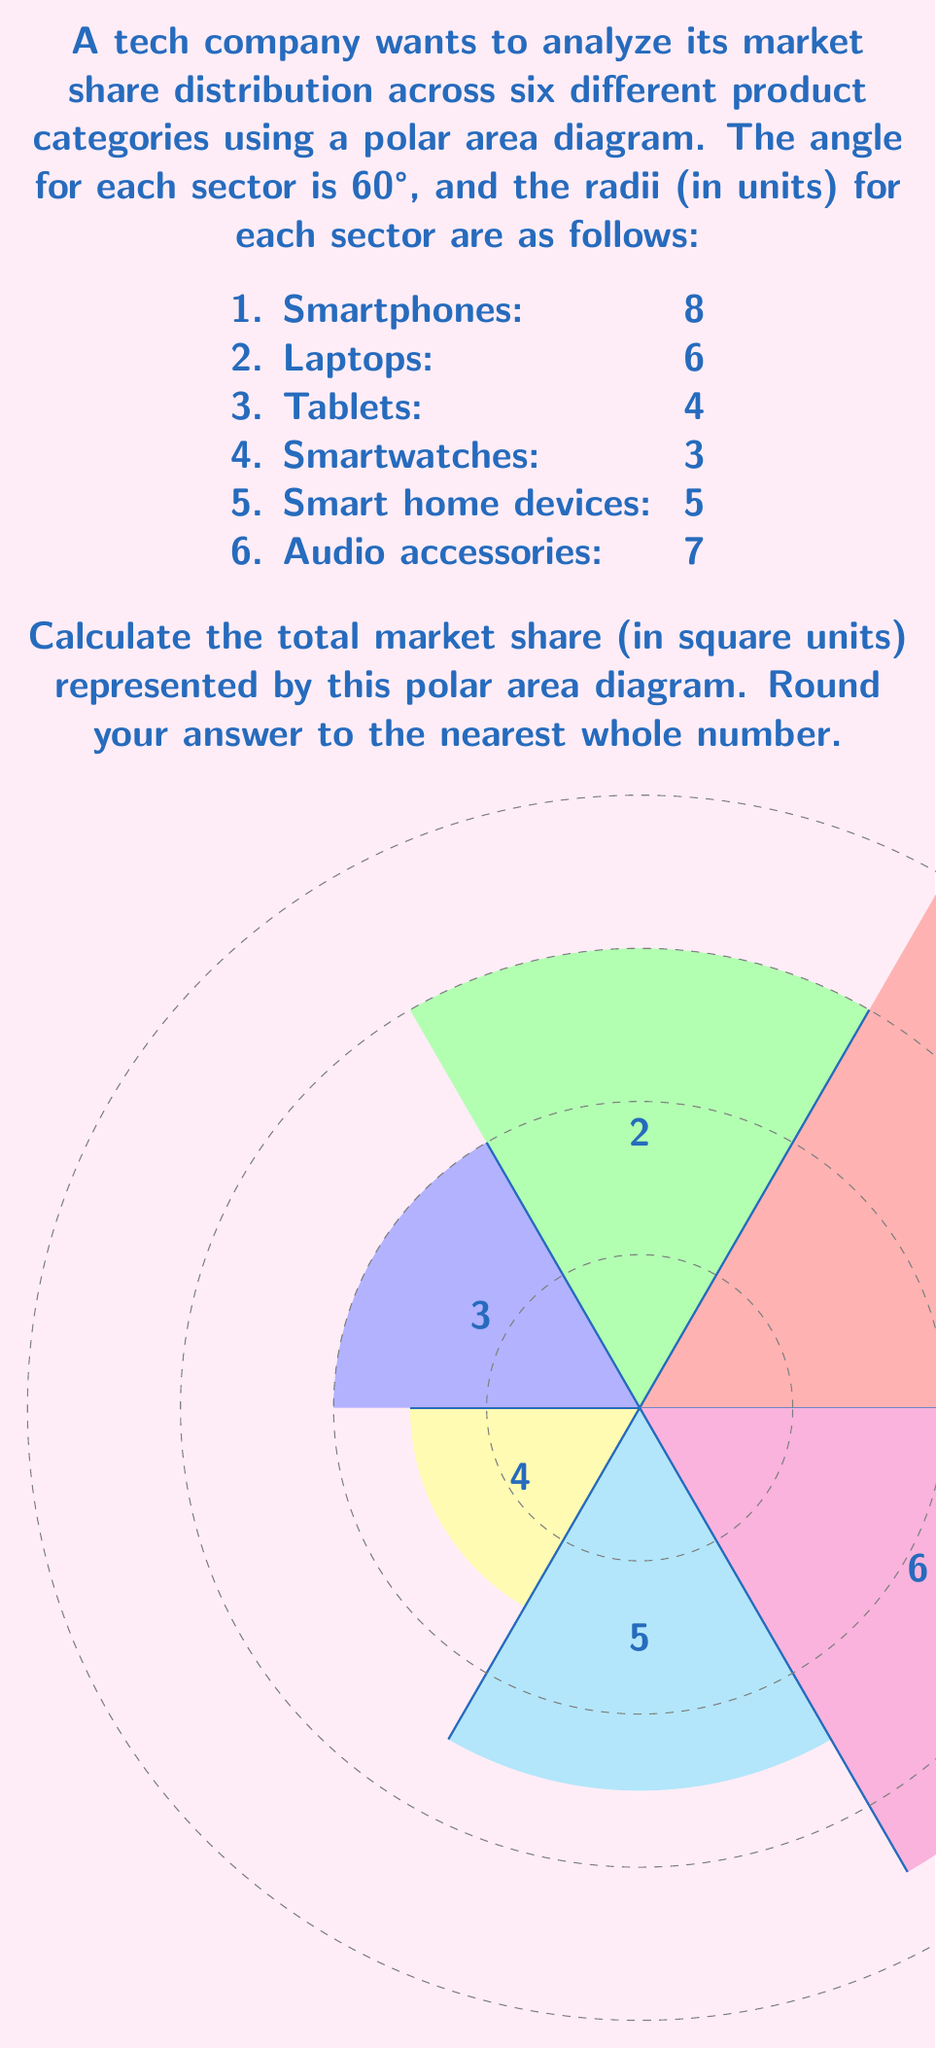Solve this math problem. To calculate the total market share represented by the polar area diagram, we need to sum the areas of all six sectors. The area of each sector is given by the formula:

$$ A = \frac{1}{2} r^2 \theta $$

Where $r$ is the radius and $\theta$ is the angle in radians.

1. Convert the angle from degrees to radians:
   $\theta = 60° \times \frac{\pi}{180°} = \frac{\pi}{3}$ radians

2. Calculate the area for each sector:
   - Smartphones: $A_1 = \frac{1}{2} \times 8^2 \times \frac{\pi}{3} = \frac{32\pi}{3}$
   - Laptops: $A_2 = \frac{1}{2} \times 6^2 \times \frac{\pi}{3} = 6\pi$
   - Tablets: $A_3 = \frac{1}{2} \times 4^2 \times \frac{\pi}{3} = \frac{8\pi}{3}$
   - Smartwatches: $A_4 = \frac{1}{2} \times 3^2 \times \frac{\pi}{3} = \frac{3\pi}{2}$
   - Smart home devices: $A_5 = \frac{1}{2} \times 5^2 \times \frac{\pi}{3} = \frac{25\pi}{6}$
   - Audio accessories: $A_6 = \frac{1}{2} \times 7^2 \times \frac{\pi}{3} = \frac{49\pi}{6}$

3. Sum all the areas:
   $A_{total} = \frac{32\pi}{3} + 6\pi + \frac{8\pi}{3} + \frac{3\pi}{2} + \frac{25\pi}{6} + \frac{49\pi}{6}$

4. Simplify:
   $A_{total} = \frac{64\pi + 36\pi + 16\pi + 9\pi + 25\pi + 49\pi}{6} = \frac{199\pi}{6}$

5. Calculate the numeric value:
   $A_{total} = \frac{199 \times 3.14159...}{6} \approx 104.03$

6. Round to the nearest whole number:
   $A_{total} \approx 104$ square units
Answer: 104 square units 